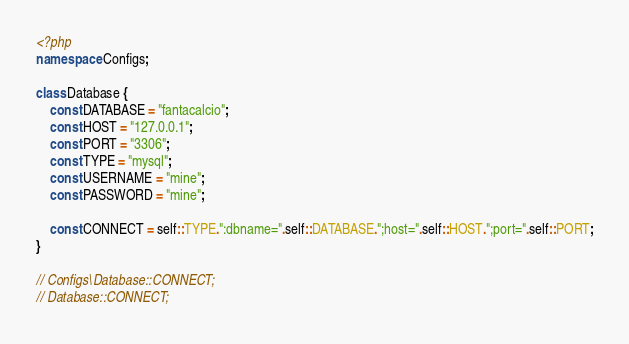Convert code to text. <code><loc_0><loc_0><loc_500><loc_500><_PHP_><?php
namespace Configs;

class Database {
    const DATABASE = "fantacalcio";
    const HOST = "127.0.0.1";
    const PORT = "3306";
    const TYPE = "mysql";
    const USERNAME = "mine";
    const PASSWORD = "mine";
            
    const CONNECT = self::TYPE.":dbname=".self::DATABASE.";host=".self::HOST.";port=".self::PORT;
}

// Configs\Database::CONNECT;
// Database::CONNECT;</code> 